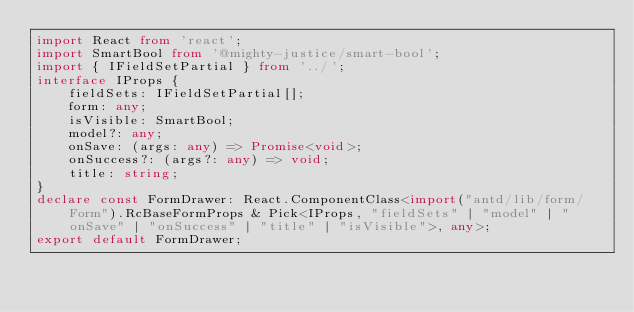Convert code to text. <code><loc_0><loc_0><loc_500><loc_500><_TypeScript_>import React from 'react';
import SmartBool from '@mighty-justice/smart-bool';
import { IFieldSetPartial } from '../';
interface IProps {
    fieldSets: IFieldSetPartial[];
    form: any;
    isVisible: SmartBool;
    model?: any;
    onSave: (args: any) => Promise<void>;
    onSuccess?: (args?: any) => void;
    title: string;
}
declare const FormDrawer: React.ComponentClass<import("antd/lib/form/Form").RcBaseFormProps & Pick<IProps, "fieldSets" | "model" | "onSave" | "onSuccess" | "title" | "isVisible">, any>;
export default FormDrawer;
</code> 